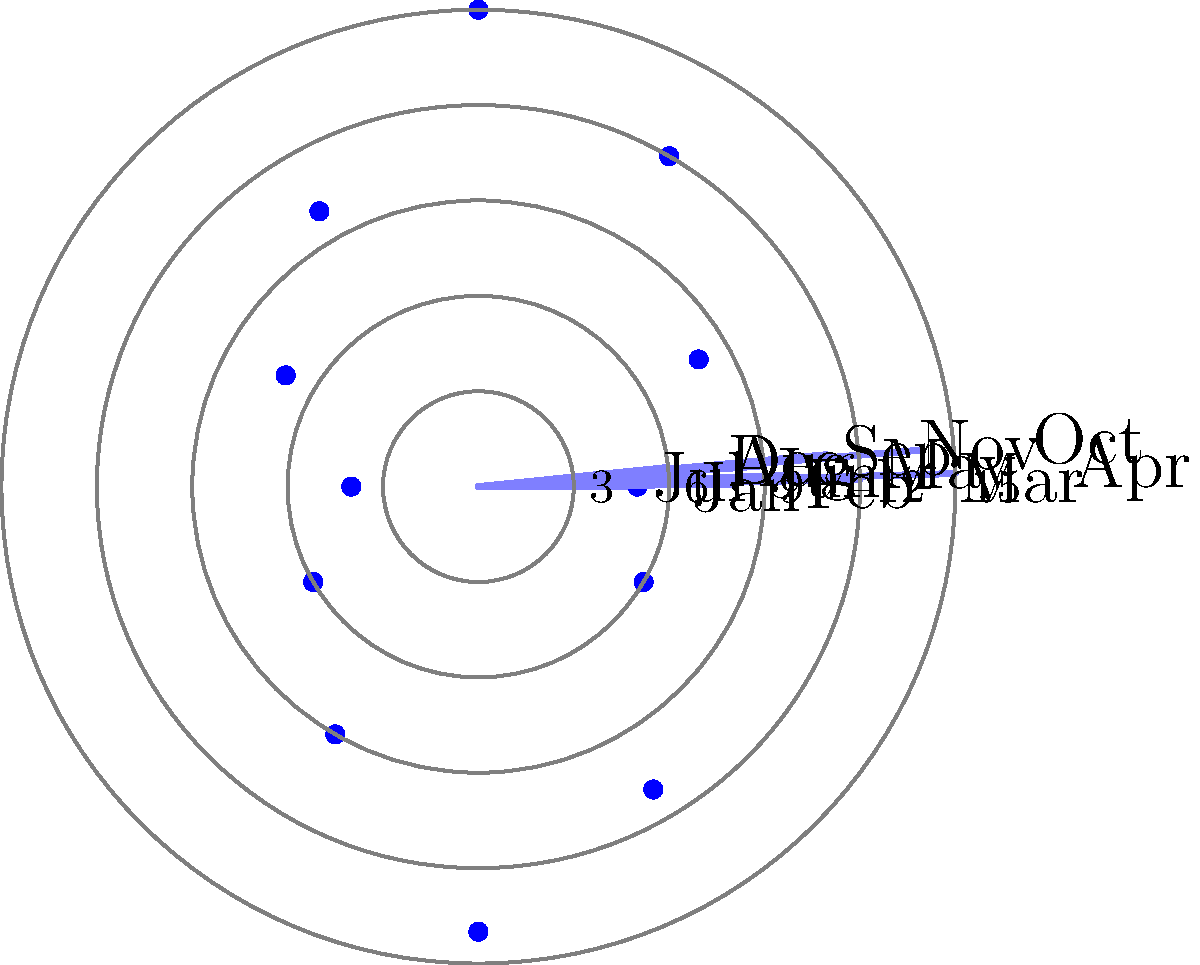As a successful business owner in South Asian trade, you're analyzing seasonal fluctuations in your trade volume. The polar rose diagram above represents monthly trade volumes in millions of dollars. Which month shows the highest trade volume, and what strategy might you implement to capitalize on this peak season? To answer this question, we need to follow these steps:

1. Examine the polar rose diagram:
   - Each petal represents a month, starting with January at the top and moving clockwise.
   - The length of each petal indicates the trade volume for that month.

2. Identify the longest petal:
   - The longest petal corresponds to April, indicating the highest trade volume.

3. Quantify the trade volume:
   - The outermost circle represents $15 million, and April's petal reaches this circle.
   - Therefore, April's trade volume is $15 million.

4. Consider a strategy to capitalize on the peak season:
   - Increase inventory and workforce in preparation for April's high demand.
   - Negotiate better terms with suppliers for bulk purchases.
   - Implement targeted marketing campaigns leading up to April.
   - Offer promotions or bundle deals to maximize sales during this period.
   - Ensure logistics and transportation are optimized for higher volumes.

The strategy should focus on maximizing profits during the peak season while maintaining efficient operations and customer satisfaction.
Answer: April; Increase inventory, workforce, and marketing efforts before peak. 